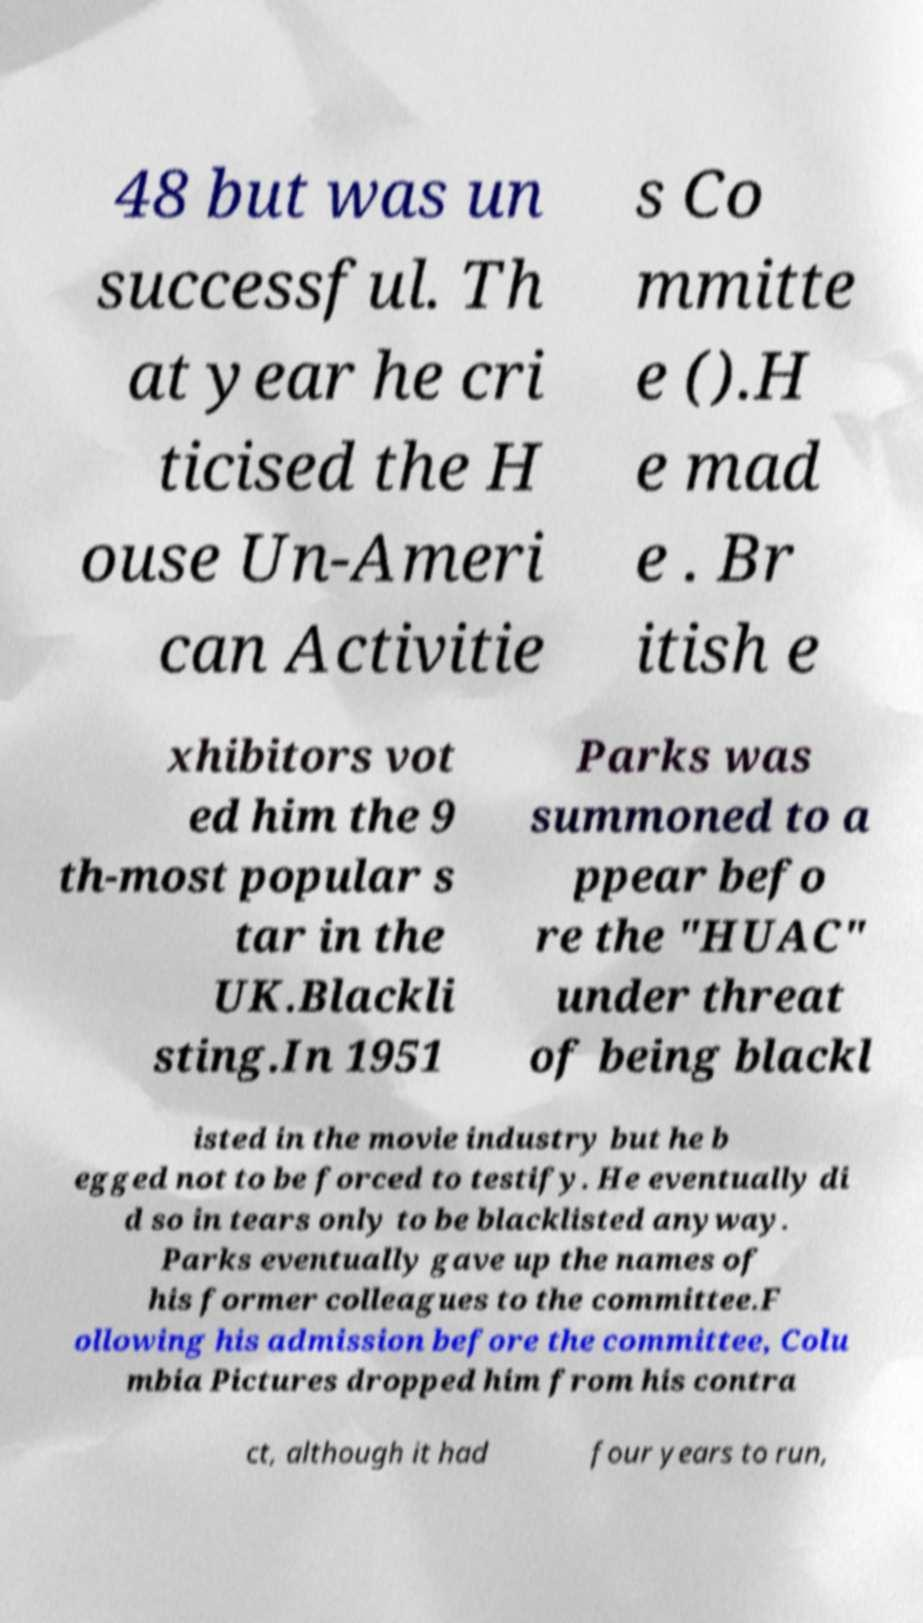I need the written content from this picture converted into text. Can you do that? 48 but was un successful. Th at year he cri ticised the H ouse Un-Ameri can Activitie s Co mmitte e ().H e mad e . Br itish e xhibitors vot ed him the 9 th-most popular s tar in the UK.Blackli sting.In 1951 Parks was summoned to a ppear befo re the "HUAC" under threat of being blackl isted in the movie industry but he b egged not to be forced to testify. He eventually di d so in tears only to be blacklisted anyway. Parks eventually gave up the names of his former colleagues to the committee.F ollowing his admission before the committee, Colu mbia Pictures dropped him from his contra ct, although it had four years to run, 